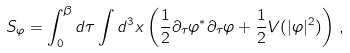Convert formula to latex. <formula><loc_0><loc_0><loc_500><loc_500>S _ { \varphi } = \int _ { 0 } ^ { \beta } d \tau \int d ^ { 3 } x \left ( \frac { 1 } { 2 } \partial _ { \tau } \varphi ^ { * } \partial _ { \tau } \varphi + \frac { 1 } { 2 } V ( | \varphi | ^ { 2 } ) \right ) \, ,</formula> 